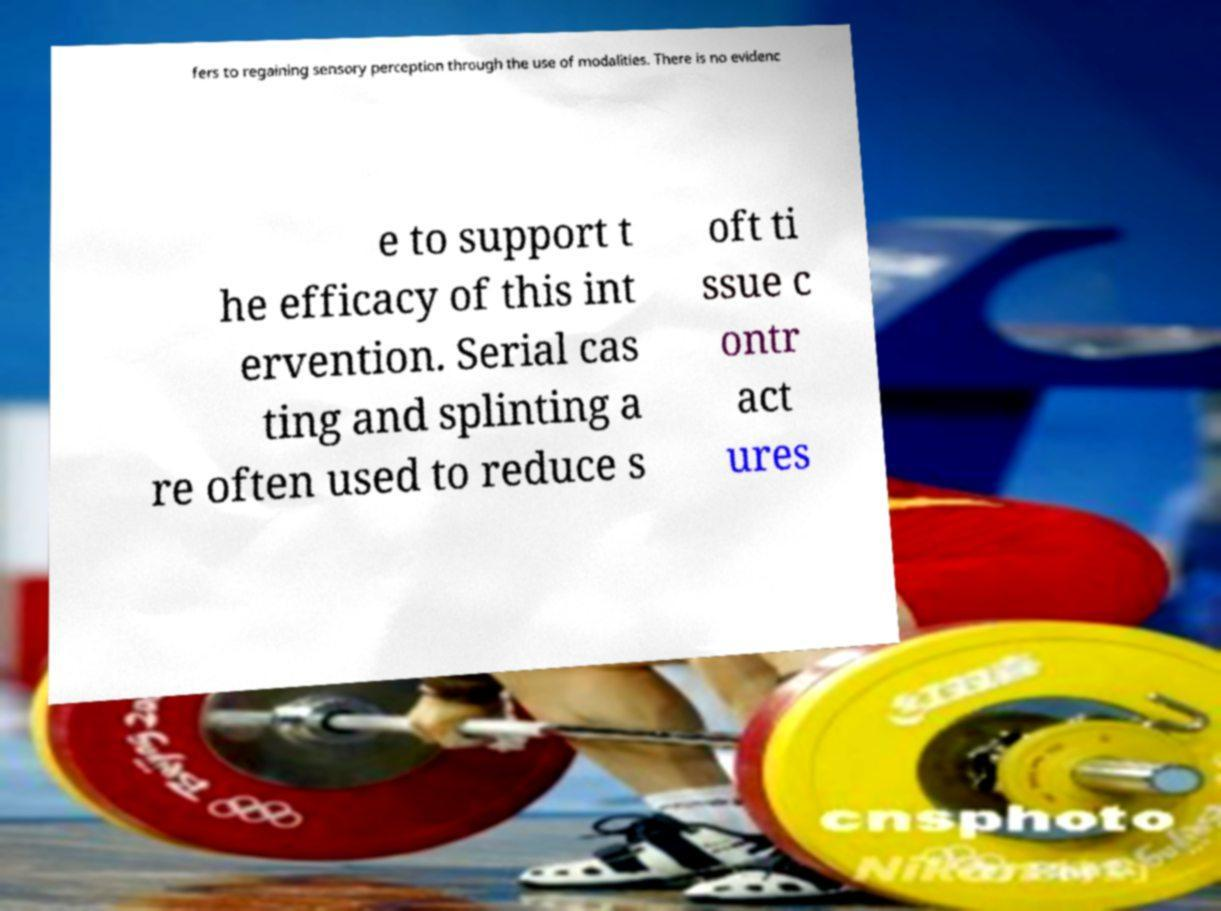Can you read and provide the text displayed in the image?This photo seems to have some interesting text. Can you extract and type it out for me? fers to regaining sensory perception through the use of modalities. There is no evidenc e to support t he efficacy of this int ervention. Serial cas ting and splinting a re often used to reduce s oft ti ssue c ontr act ures 